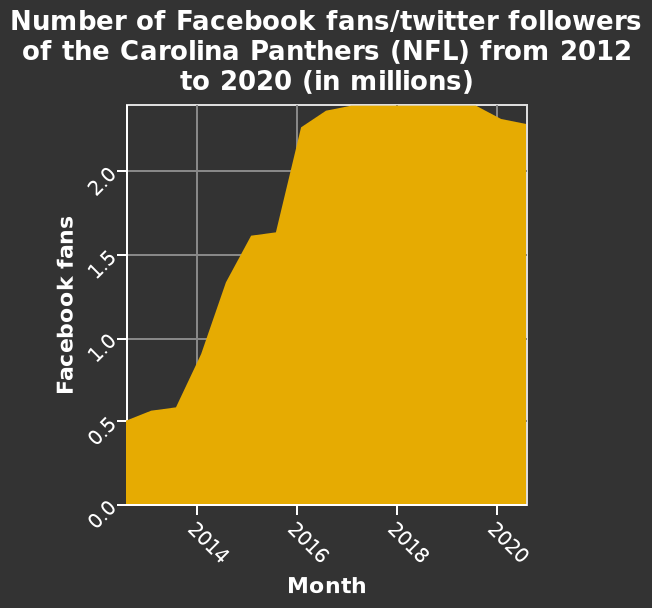<image>
In which year did the Carolina Panthers have the highest number of Facebook fans? The data does not specify the exact year in which the Carolina Panthers had the highest number of Facebook fans. 